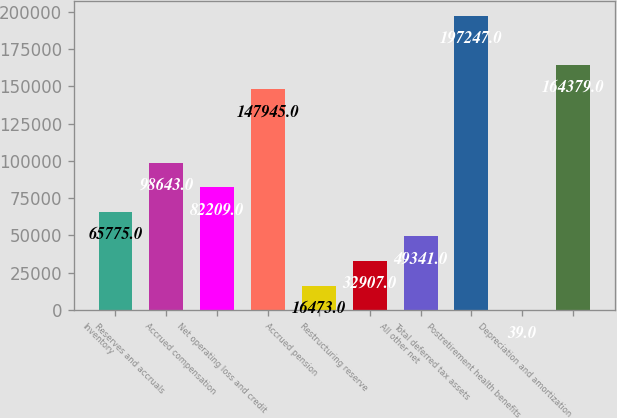Convert chart to OTSL. <chart><loc_0><loc_0><loc_500><loc_500><bar_chart><fcel>Inventory<fcel>Reserves and accruals<fcel>Accrued compensation<fcel>Net operating loss and credit<fcel>Accrued pension<fcel>Restructuring reserve<fcel>All other net<fcel>Total deferred tax assets<fcel>Postretirement health benefits<fcel>Depreciation and amortization<nl><fcel>65775<fcel>98643<fcel>82209<fcel>147945<fcel>16473<fcel>32907<fcel>49341<fcel>197247<fcel>39<fcel>164379<nl></chart> 